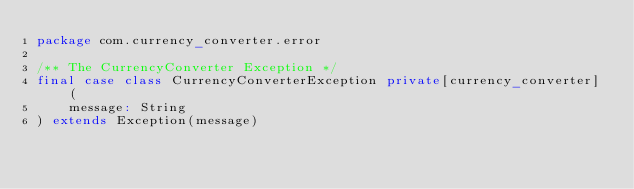Convert code to text. <code><loc_0><loc_0><loc_500><loc_500><_Scala_>package com.currency_converter.error

/** The CurrencyConverter Exception */
final case class CurrencyConverterException private[currency_converter] (
    message: String
) extends Exception(message)
</code> 